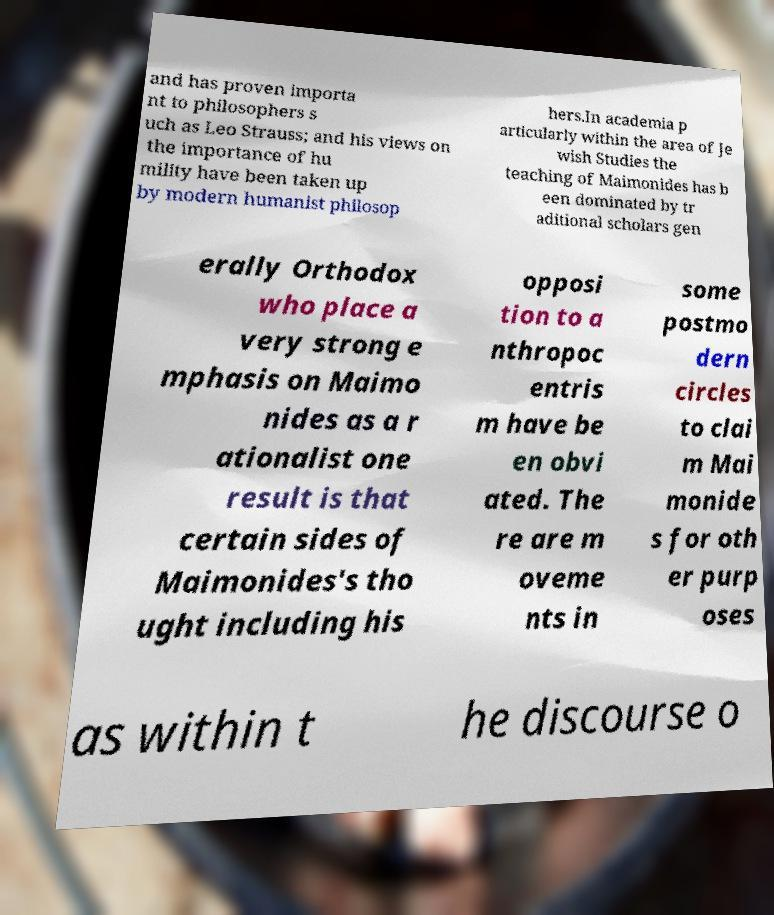Could you extract and type out the text from this image? and has proven importa nt to philosophers s uch as Leo Strauss; and his views on the importance of hu mility have been taken up by modern humanist philosop hers.In academia p articularly within the area of Je wish Studies the teaching of Maimonides has b een dominated by tr aditional scholars gen erally Orthodox who place a very strong e mphasis on Maimo nides as a r ationalist one result is that certain sides of Maimonides's tho ught including his opposi tion to a nthropoc entris m have be en obvi ated. The re are m oveme nts in some postmo dern circles to clai m Mai monide s for oth er purp oses as within t he discourse o 